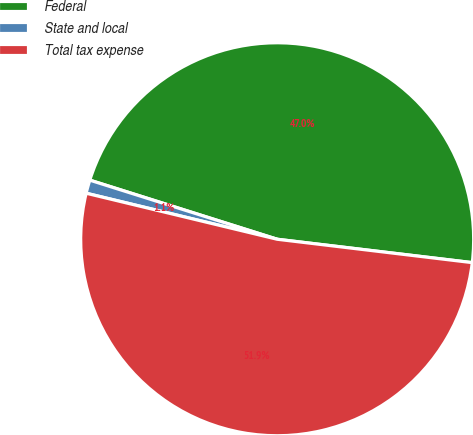Convert chart to OTSL. <chart><loc_0><loc_0><loc_500><loc_500><pie_chart><fcel>Federal<fcel>State and local<fcel>Total tax expense<nl><fcel>47.04%<fcel>1.1%<fcel>51.87%<nl></chart> 